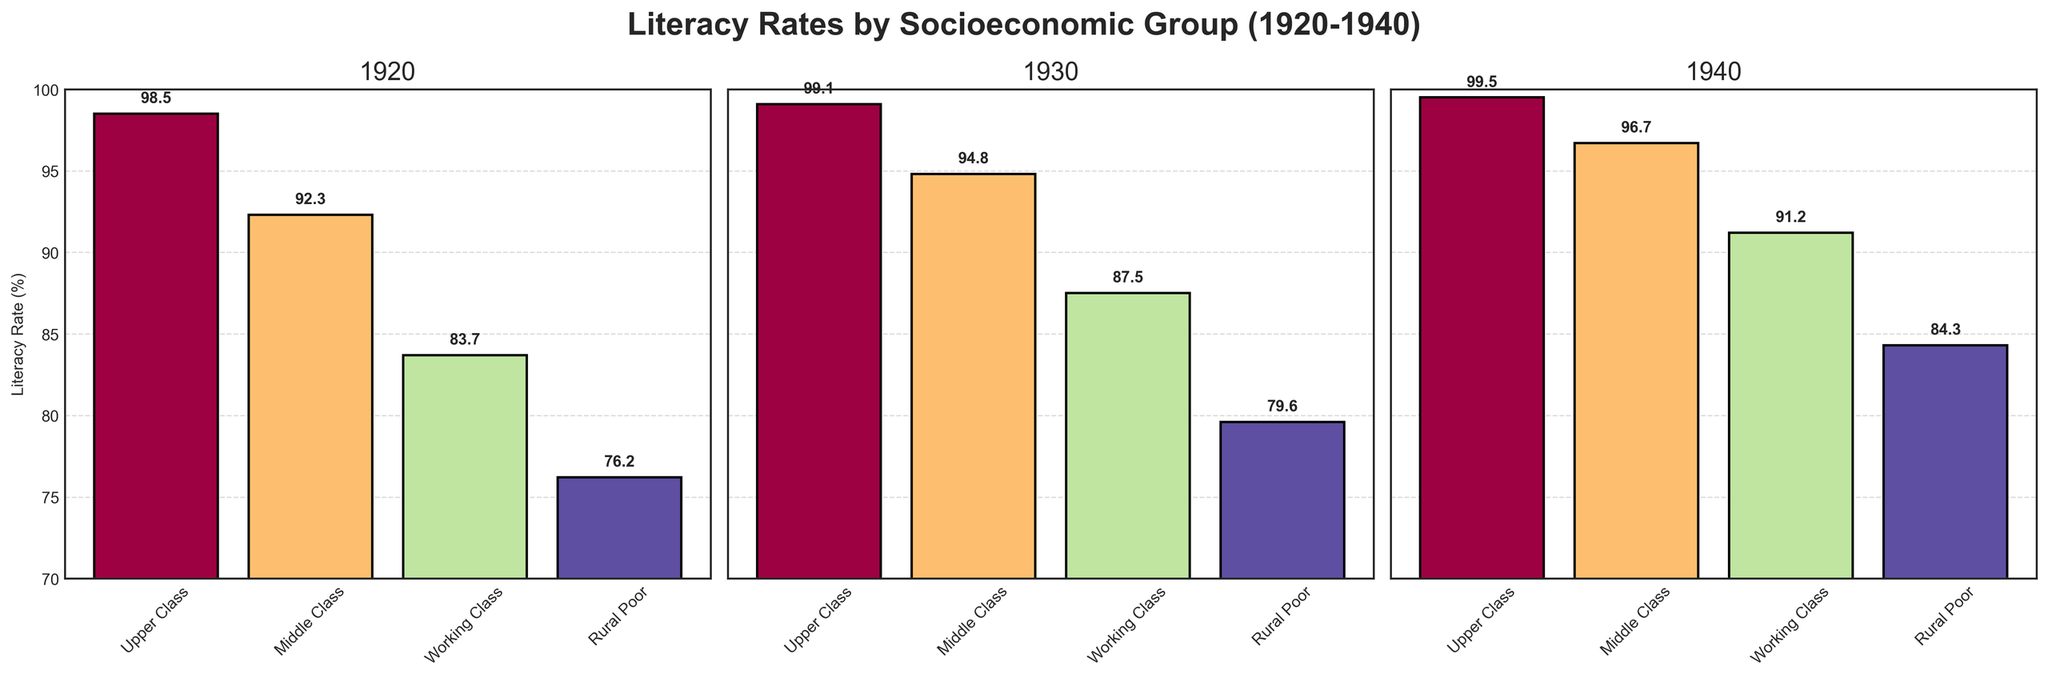Which group had the lowest literacy rate in 1920? By looking at the bars in the 1920 subplot, see which group has the smallest height. The Rural Poor group has the lowest literacy rate at 76.2% in 1920.
Answer: Rural Poor How did the literacy rate change for the Middle Class from 1920 to 1940? To find the change, look at the Middle Class bars in 1920 and 1940 subplots. Subtract the 1920 literacy rate (92.3%) from the 1940 literacy rate (96.7%). The Middle Class literacy rate increased by 4.4%.
Answer: Increased by 4.4% Which socioeconomic group showed the greatest improvement in literacy rates from 1920 to 1940? Calculate the difference in literacy rates for each group from 1920 to 1940: Upper Class (99.5 - 98.5 = 1.0), Middle Class (96.7 - 92.3 = 4.4), Working Class (91.2 - 83.7 = 7.5), Rural Poor (84.3 - 76.2 = 8.1). The Rural Poor group showed the greatest improvement.
Answer: Rural Poor What is the average literacy rate for the Working Class across all three decades? Add the literacy rates for the Working Class for 1920, 1930, and 1940 and then divide by 3: (83.7 + 87.5 + 91.2) / 3 = 87.47%.
Answer: 87.47% Compare the literacy rate of the Upper Class in 1930 to the Working Class in the same year. Examine the bars for the Upper Class and Working Class in the 1930 subplot. The Upper Class literacy rate is 99.1%, while the Working Class literacy rate is 87.5%. The Upper Class rate is higher.
Answer: Upper Class rate is higher What is the trend in literacy rates for the Middle Class from 1920 to 1940? Look at the Middle Class bars in the 1920, 1930, and 1940 subplots and observe the heights of the bars. The trend shows an increase from 92.3% in 1920 to 94.8% in 1930 to 96.7% in 1940.
Answer: Increasing What is the difference between the highest and lowest literacy rates in 1940? Identify the highest and lowest literacy rates from the 1940 subplot. The highest is Upper Class at 99.5% and the lowest is Rural Poor at 84.3%. The difference is 99.5% - 84.3% = 15.2%.
Answer: 15.2% Did any group reach a literacy rate of 100% by 1940? Check the bars in the 1940 subplot to see if any group's literacy rate reaches 100%. None of the bars show a rate of 100%.
Answer: No 